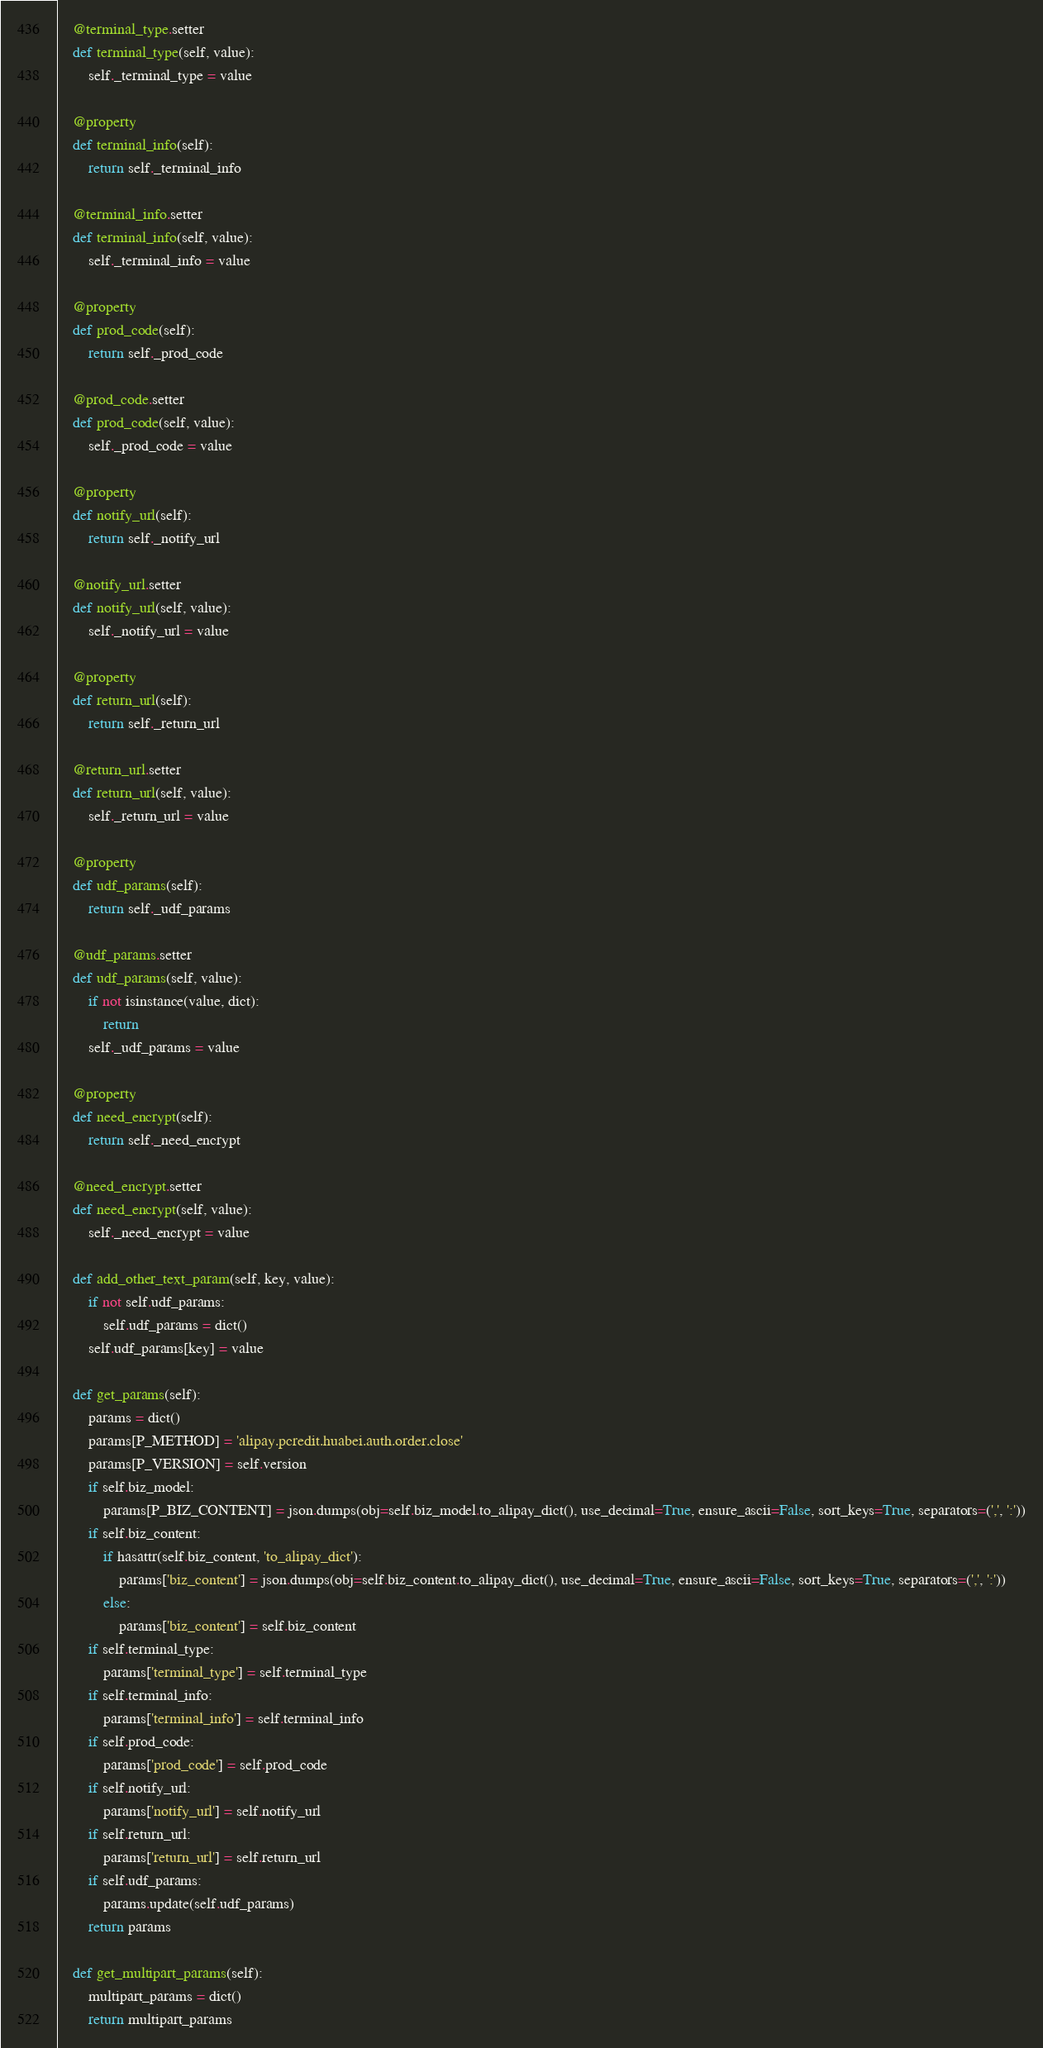<code> <loc_0><loc_0><loc_500><loc_500><_Python_>    @terminal_type.setter
    def terminal_type(self, value):
        self._terminal_type = value

    @property
    def terminal_info(self):
        return self._terminal_info

    @terminal_info.setter
    def terminal_info(self, value):
        self._terminal_info = value

    @property
    def prod_code(self):
        return self._prod_code

    @prod_code.setter
    def prod_code(self, value):
        self._prod_code = value

    @property
    def notify_url(self):
        return self._notify_url

    @notify_url.setter
    def notify_url(self, value):
        self._notify_url = value

    @property
    def return_url(self):
        return self._return_url

    @return_url.setter
    def return_url(self, value):
        self._return_url = value

    @property
    def udf_params(self):
        return self._udf_params

    @udf_params.setter
    def udf_params(self, value):
        if not isinstance(value, dict):
            return
        self._udf_params = value

    @property
    def need_encrypt(self):
        return self._need_encrypt

    @need_encrypt.setter
    def need_encrypt(self, value):
        self._need_encrypt = value

    def add_other_text_param(self, key, value):
        if not self.udf_params:
            self.udf_params = dict()
        self.udf_params[key] = value

    def get_params(self):
        params = dict()
        params[P_METHOD] = 'alipay.pcredit.huabei.auth.order.close'
        params[P_VERSION] = self.version
        if self.biz_model:
            params[P_BIZ_CONTENT] = json.dumps(obj=self.biz_model.to_alipay_dict(), use_decimal=True, ensure_ascii=False, sort_keys=True, separators=(',', ':'))
        if self.biz_content:
            if hasattr(self.biz_content, 'to_alipay_dict'):
                params['biz_content'] = json.dumps(obj=self.biz_content.to_alipay_dict(), use_decimal=True, ensure_ascii=False, sort_keys=True, separators=(',', ':'))
            else:
                params['biz_content'] = self.biz_content
        if self.terminal_type:
            params['terminal_type'] = self.terminal_type
        if self.terminal_info:
            params['terminal_info'] = self.terminal_info
        if self.prod_code:
            params['prod_code'] = self.prod_code
        if self.notify_url:
            params['notify_url'] = self.notify_url
        if self.return_url:
            params['return_url'] = self.return_url
        if self.udf_params:
            params.update(self.udf_params)
        return params

    def get_multipart_params(self):
        multipart_params = dict()
        return multipart_params
</code> 